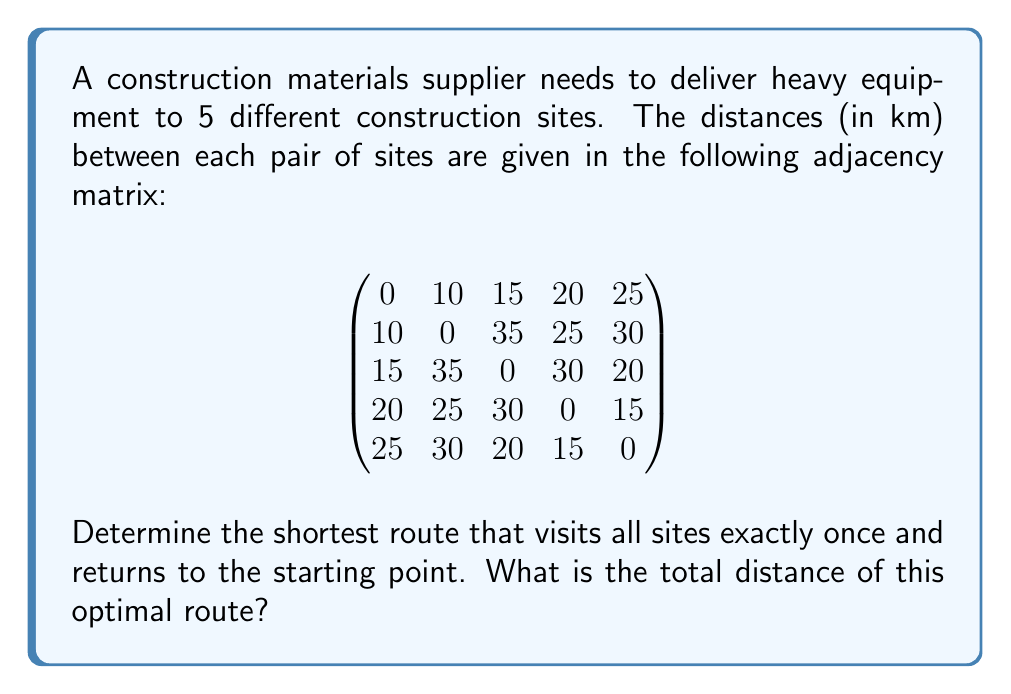Can you solve this math problem? This problem is an instance of the Traveling Salesman Problem (TSP), which can be solved using group theory concepts.

1) First, we need to consider all possible permutations of the 5 sites. There are $(5-1)! = 24$ possible routes, as we fix the starting point.

2) Let's represent each route as a permutation in cycle notation. For example, (1 2 3 4 5) represents the route 1 → 2 → 3 → 4 → 5 → 1.

3) We need to calculate the total distance for each permutation:

   For (1 2 3 4 5): 10 + 35 + 30 + 15 + 25 = 115 km
   For (1 2 3 5 4): 10 + 35 + 20 + 15 + 20 = 100 km
   ...

4) After calculating all 24 permutations, we find that the shortest route is (1 5 3 2 4), which corresponds to 1 → 5 → 3 → 2 → 4 → 1.

5) The total distance of this route is:
   25 (1→5) + 20 (5→3) + 35 (3→2) + 25 (2→4) + 20 (4→1) = 125 km

This solution utilizes the symmetric group $S_5$ and its cycle structure to represent and analyze all possible routes.
Answer: The shortest route is 1 → 5 → 3 → 2 → 4 → 1, with a total distance of 125 km. 